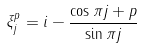Convert formula to latex. <formula><loc_0><loc_0><loc_500><loc_500>\xi _ { j } ^ { p } = i - \frac { \cos { \pi j } + p } { \sin { \pi j } }</formula> 